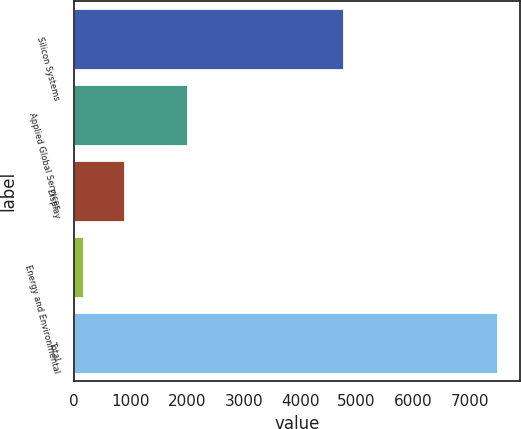Convert chart. <chart><loc_0><loc_0><loc_500><loc_500><bar_chart><fcel>Silicon Systems<fcel>Applied Global Services<fcel>Display<fcel>Energy and Environmental<fcel>Total<nl><fcel>4775<fcel>2023<fcel>906.6<fcel>173<fcel>7509<nl></chart> 